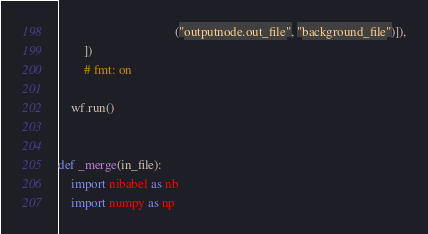<code> <loc_0><loc_0><loc_500><loc_500><_Python_>                                    ("outputnode.out_file", "background_file")]),
        ])
        # fmt: on

    wf.run()


def _merge(in_file):
    import nibabel as nb
    import numpy as np
</code> 